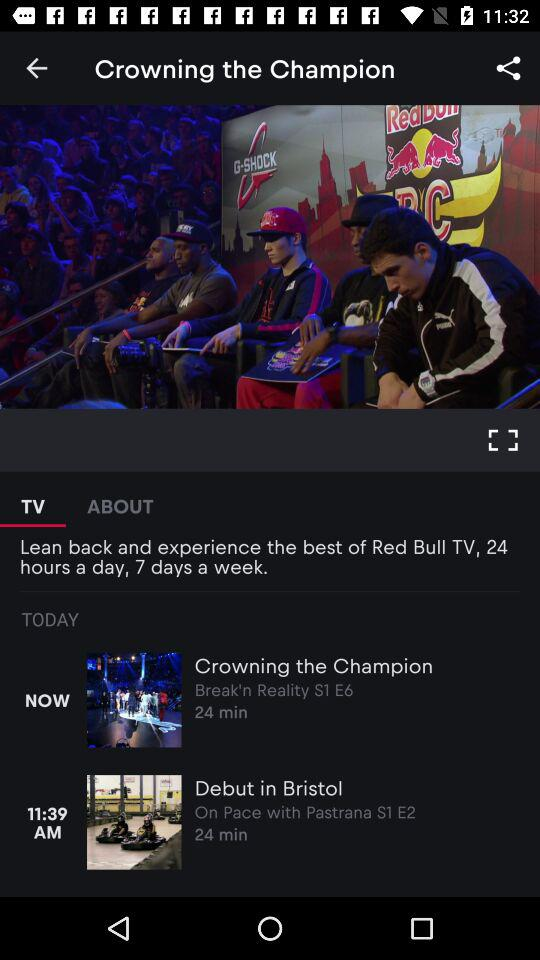What is the length of the video "Crowning the Champion"? The length of the video is 24 minutes. 